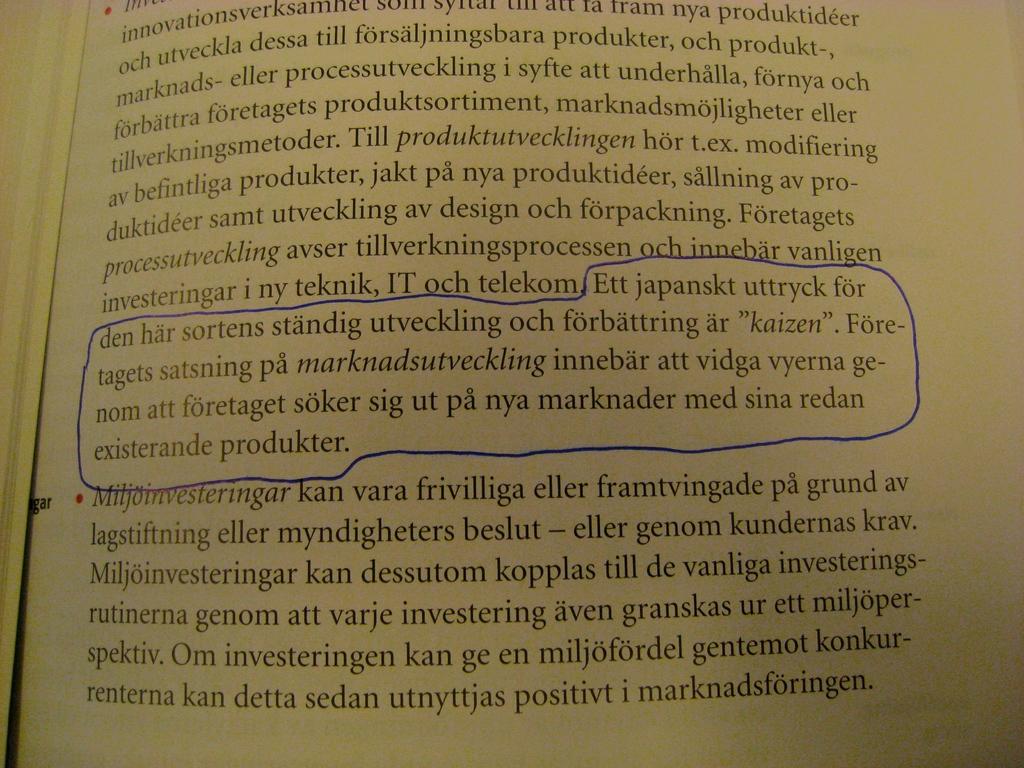What is the last word on the page?
Offer a very short reply. Marknadsforingen. What is the last wood on the page?
Offer a terse response. Marknadsforingen. 